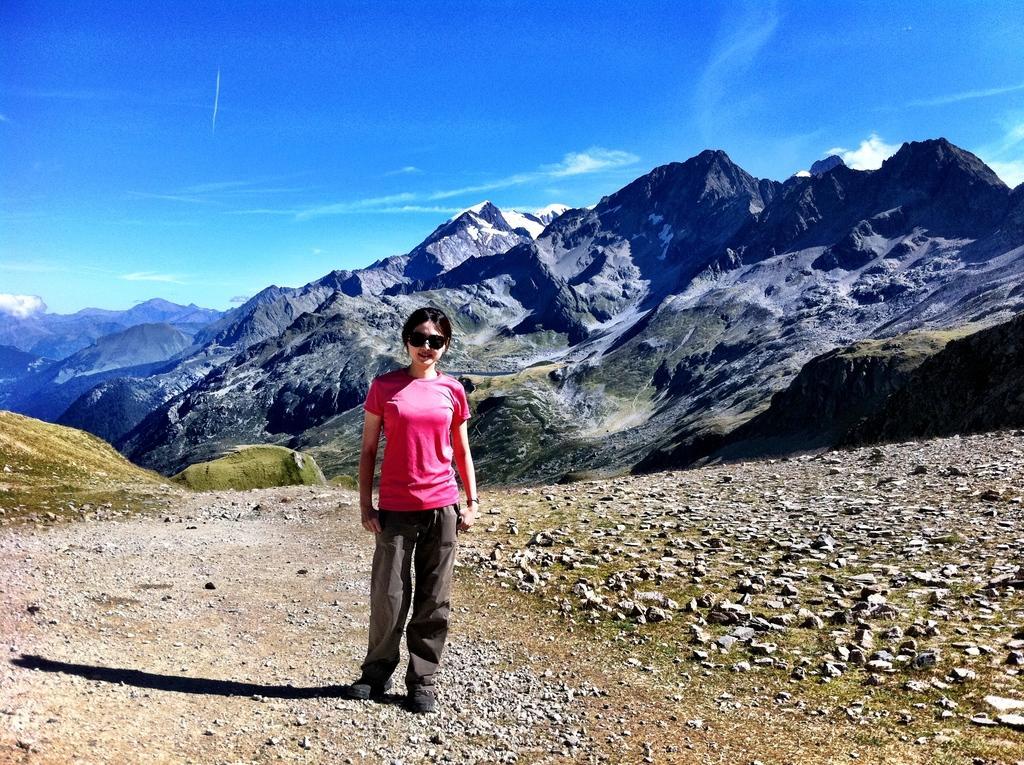Describe this image in one or two sentences. In this image, we can see a woman is standing and smiling. She wore goggles. Here we can see stones and walkway. Background we can see hills and sky. 